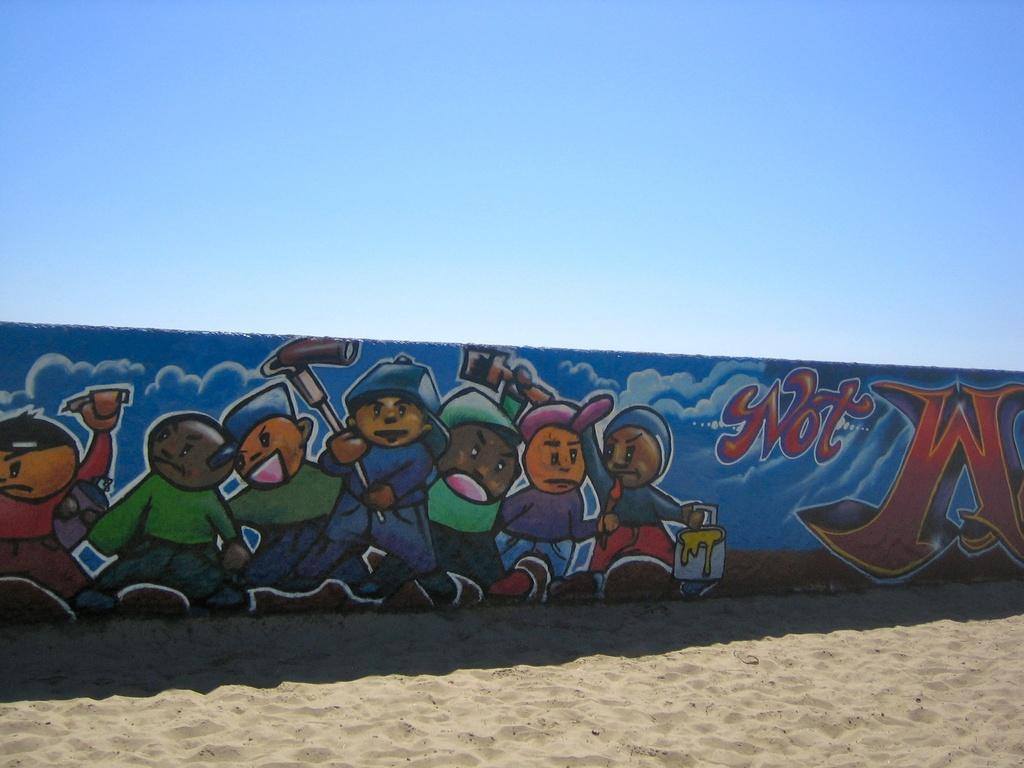What type of surface is visible in the image? There is sand in the image. What structure can be seen in the image? There is a wall in the image. What is depicted on the wall? There is a painting of few persons on the wall. What can be seen in the background of the image? The sky is visible in the background of the image. What type of money is being taught in the image? There is no money or teaching activity present in the image. What type of pest can be seen crawling on the sand in the image? There are no pests visible in the image; it only features sand, a wall, and a painting of persons. 